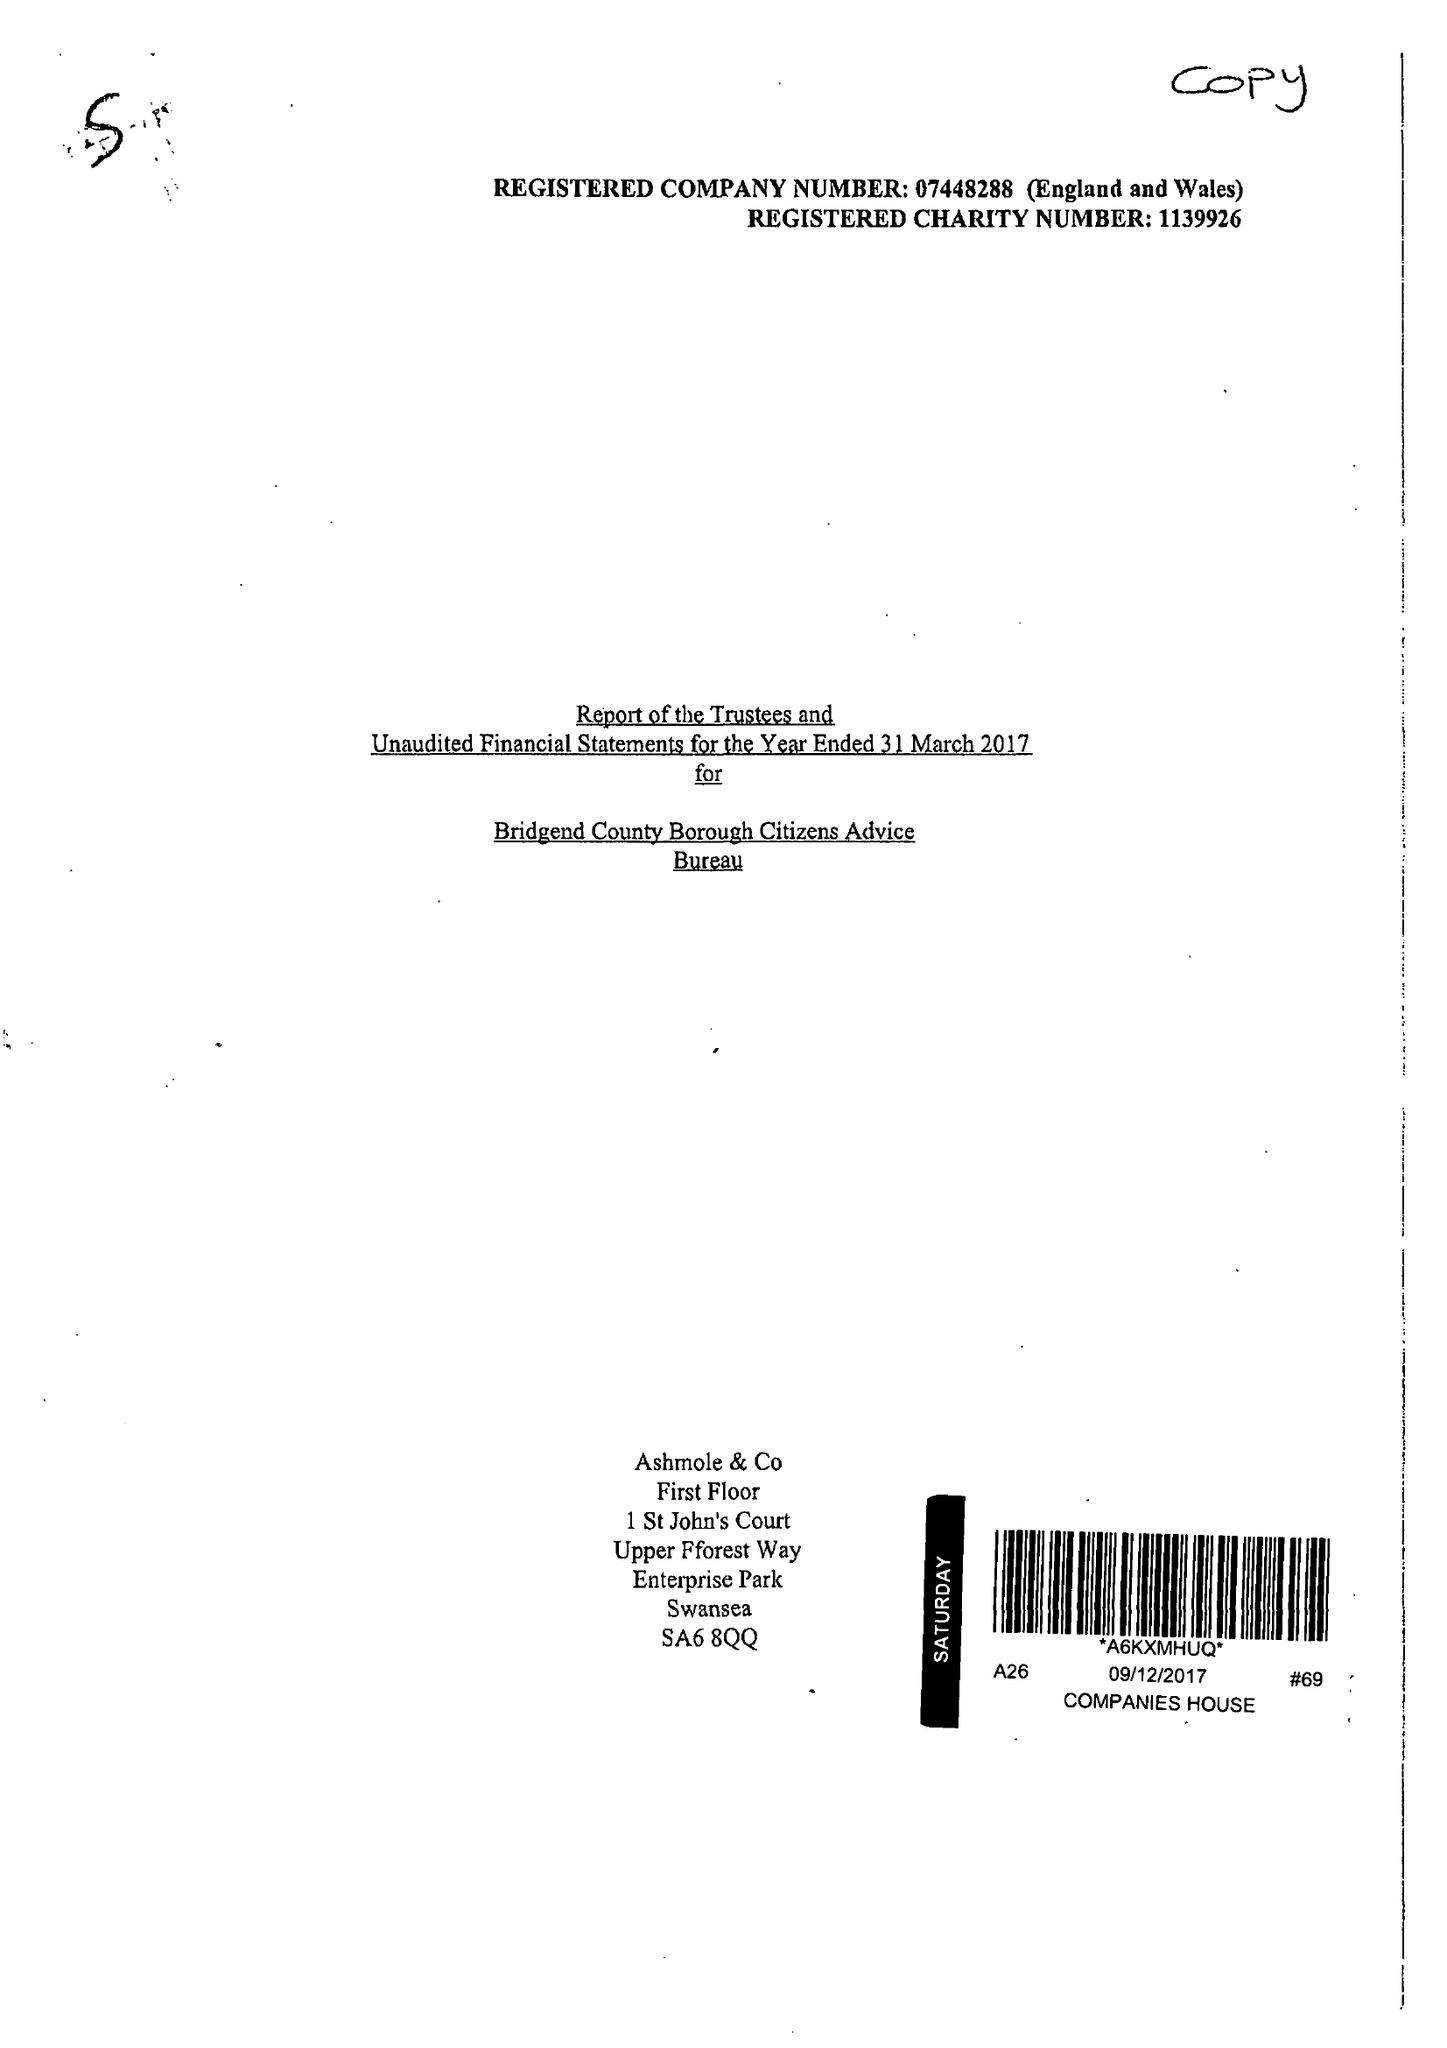What is the value for the charity_name?
Answer the question using a single word or phrase. Bridgend County Borough Citizens Advice Bureau 